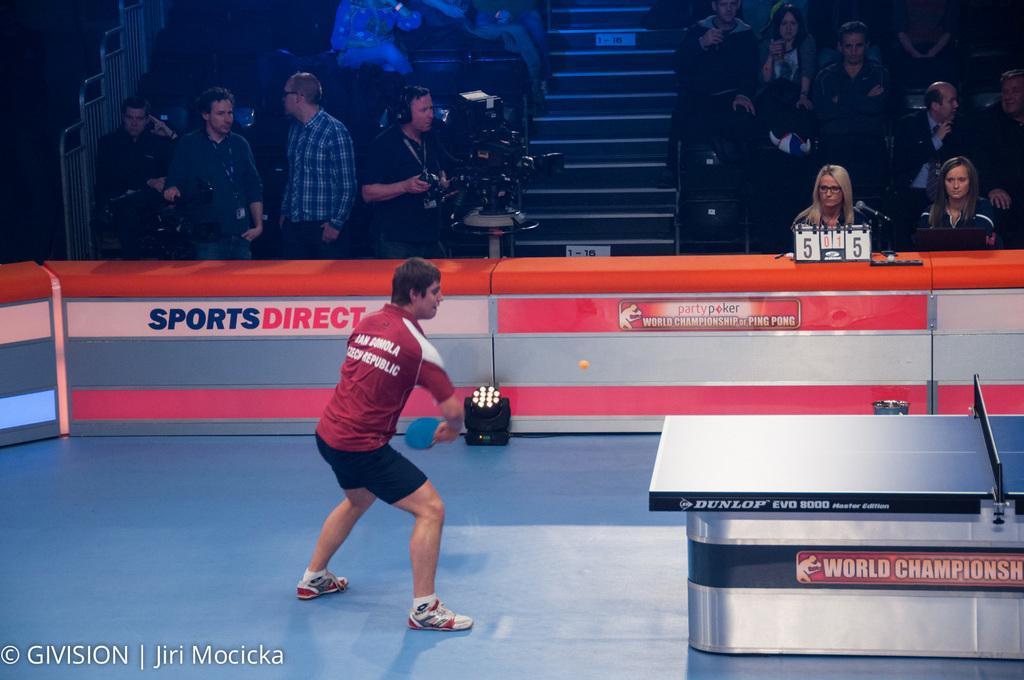Can you describe this image briefly? In the center of the image we can see person standing and holding a table tennis bat. On the left side of the image we can see persons standing with cameras. On the right side of the image we can see table tennis board. In the background we can see stairs, chairs and persons. 